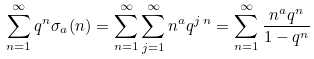Convert formula to latex. <formula><loc_0><loc_0><loc_500><loc_500>\sum _ { n = 1 } ^ { \infty } q ^ { n } \sigma _ { a } ( n ) = \sum _ { n = 1 } ^ { \infty } \sum _ { j = 1 } ^ { \infty } n ^ { a } q ^ { j \, n } = \sum _ { n = 1 } ^ { \infty } { \frac { n ^ { a } q ^ { n } } { 1 - q ^ { n } } }</formula> 